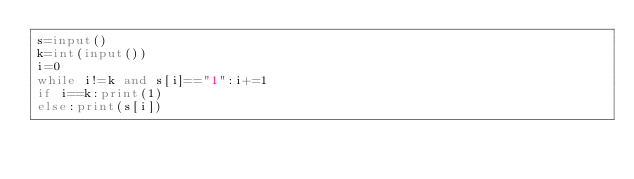<code> <loc_0><loc_0><loc_500><loc_500><_Python_>s=input()
k=int(input())
i=0
while i!=k and s[i]=="1":i+=1
if i==k:print(1)
else:print(s[i])</code> 